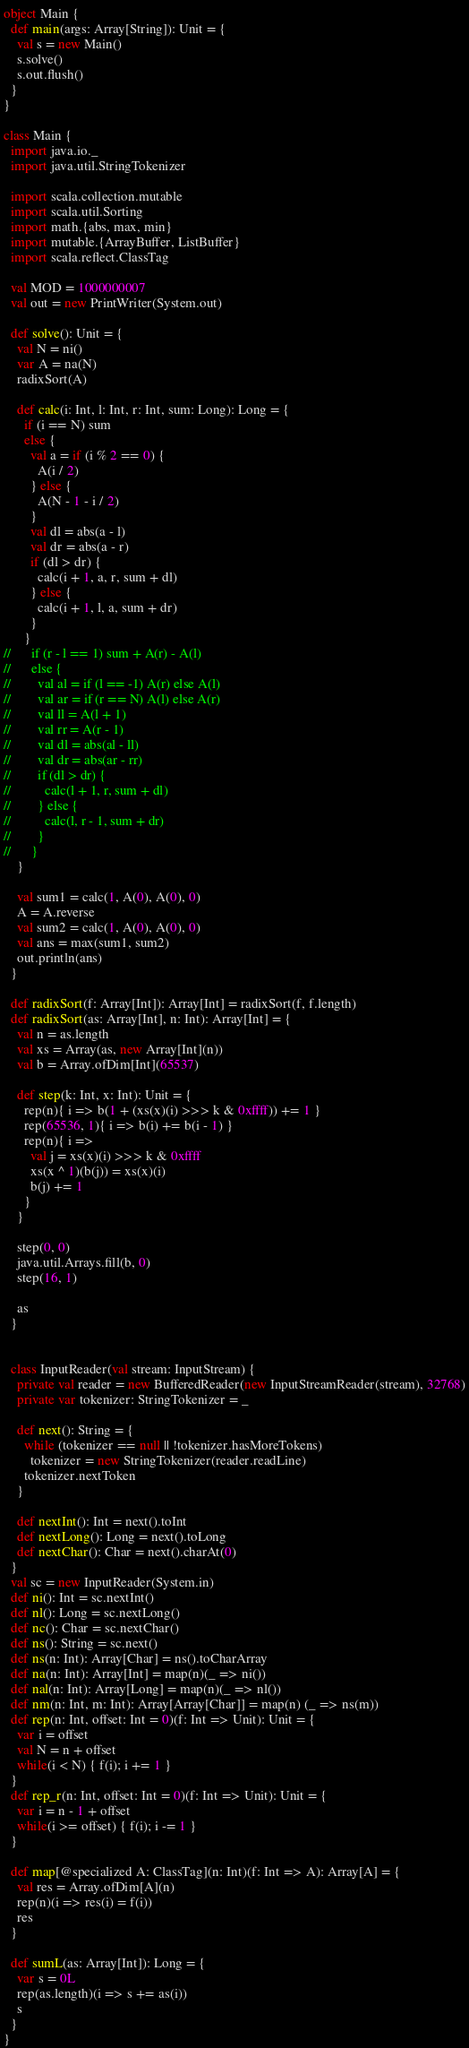<code> <loc_0><loc_0><loc_500><loc_500><_Scala_>object Main {
  def main(args: Array[String]): Unit = {
    val s = new Main()
    s.solve()
    s.out.flush()
  }
}

class Main {
  import java.io._
  import java.util.StringTokenizer

  import scala.collection.mutable
  import scala.util.Sorting
  import math.{abs, max, min}
  import mutable.{ArrayBuffer, ListBuffer}
  import scala.reflect.ClassTag

  val MOD = 1000000007
  val out = new PrintWriter(System.out)

  def solve(): Unit = {
    val N = ni()
    var A = na(N)
    radixSort(A)

    def calc(i: Int, l: Int, r: Int, sum: Long): Long = {
      if (i == N) sum
      else {
        val a = if (i % 2 == 0) {
          A(i / 2)
        } else {
          A(N - 1 - i / 2)
        }
        val dl = abs(a - l)
        val dr = abs(a - r)
        if (dl > dr) {
          calc(i + 1, a, r, sum + dl)
        } else {
          calc(i + 1, l, a, sum + dr)
        }
      }
//      if (r - l == 1) sum + A(r) - A(l)
//      else {
//        val al = if (l == -1) A(r) else A(l)
//        val ar = if (r == N) A(l) else A(r)
//        val ll = A(l + 1)
//        val rr = A(r - 1)
//        val dl = abs(al - ll)
//        val dr = abs(ar - rr)
//        if (dl > dr) {
//          calc(l + 1, r, sum + dl)
//        } else {
//          calc(l, r - 1, sum + dr)
//        }
//      }
    }

    val sum1 = calc(1, A(0), A(0), 0)
    A = A.reverse
    val sum2 = calc(1, A(0), A(0), 0)
    val ans = max(sum1, sum2)
    out.println(ans)
  }

  def radixSort(f: Array[Int]): Array[Int] = radixSort(f, f.length)
  def radixSort(as: Array[Int], n: Int): Array[Int] = {
    val n = as.length
    val xs = Array(as, new Array[Int](n))
    val b = Array.ofDim[Int](65537)

    def step(k: Int, x: Int): Unit = {
      rep(n){ i => b(1 + (xs(x)(i) >>> k & 0xffff)) += 1 }
      rep(65536, 1){ i => b(i) += b(i - 1) }
      rep(n){ i =>
        val j = xs(x)(i) >>> k & 0xffff
        xs(x ^ 1)(b(j)) = xs(x)(i)
        b(j) += 1
      }
    }

    step(0, 0)
    java.util.Arrays.fill(b, 0)
    step(16, 1)

    as
  }


  class InputReader(val stream: InputStream) {
    private val reader = new BufferedReader(new InputStreamReader(stream), 32768)
    private var tokenizer: StringTokenizer = _

    def next(): String = {
      while (tokenizer == null || !tokenizer.hasMoreTokens)
        tokenizer = new StringTokenizer(reader.readLine)
      tokenizer.nextToken
    }

    def nextInt(): Int = next().toInt
    def nextLong(): Long = next().toLong
    def nextChar(): Char = next().charAt(0)
  }
  val sc = new InputReader(System.in)
  def ni(): Int = sc.nextInt()
  def nl(): Long = sc.nextLong()
  def nc(): Char = sc.nextChar()
  def ns(): String = sc.next()
  def ns(n: Int): Array[Char] = ns().toCharArray
  def na(n: Int): Array[Int] = map(n)(_ => ni())
  def nal(n: Int): Array[Long] = map(n)(_ => nl())
  def nm(n: Int, m: Int): Array[Array[Char]] = map(n) (_ => ns(m))
  def rep(n: Int, offset: Int = 0)(f: Int => Unit): Unit = {
    var i = offset
    val N = n + offset
    while(i < N) { f(i); i += 1 }
  }
  def rep_r(n: Int, offset: Int = 0)(f: Int => Unit): Unit = {
    var i = n - 1 + offset
    while(i >= offset) { f(i); i -= 1 }
  }

  def map[@specialized A: ClassTag](n: Int)(f: Int => A): Array[A] = {
    val res = Array.ofDim[A](n)
    rep(n)(i => res(i) = f(i))
    res
  }

  def sumL(as: Array[Int]): Long = {
    var s = 0L
    rep(as.length)(i => s += as(i))
    s
  }
}</code> 